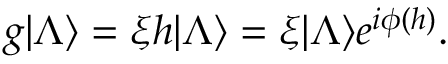<formula> <loc_0><loc_0><loc_500><loc_500>g | \Lambda \rangle = \xi h | \Lambda \rangle = \xi | \Lambda \rangle e ^ { i \phi ( h ) } .</formula> 